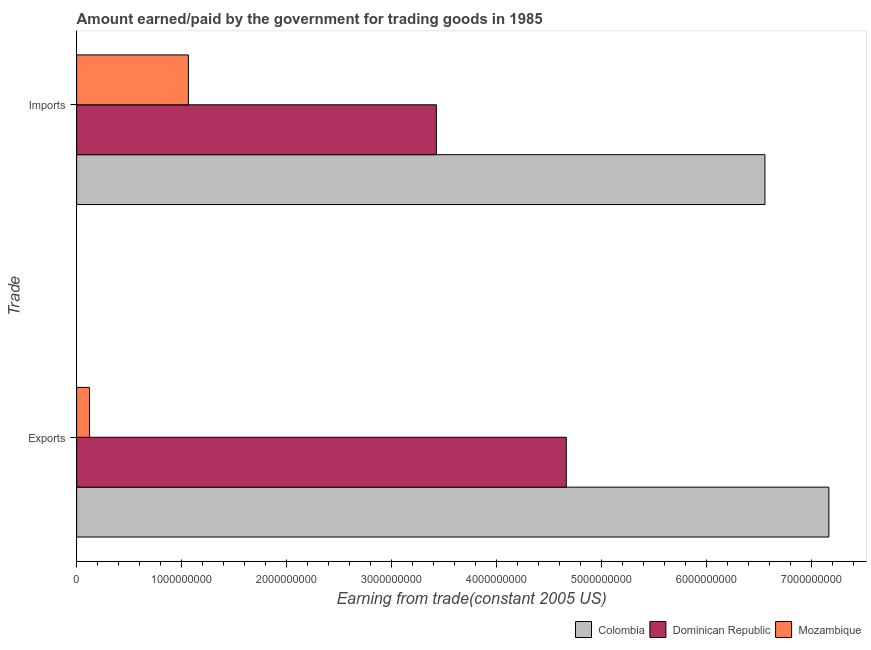How many different coloured bars are there?
Provide a short and direct response. 3. Are the number of bars per tick equal to the number of legend labels?
Your response must be concise. Yes. Are the number of bars on each tick of the Y-axis equal?
Make the answer very short. Yes. How many bars are there on the 2nd tick from the bottom?
Provide a short and direct response. 3. What is the label of the 2nd group of bars from the top?
Ensure brevity in your answer.  Exports. What is the amount paid for imports in Dominican Republic?
Ensure brevity in your answer.  3.43e+09. Across all countries, what is the maximum amount earned from exports?
Ensure brevity in your answer.  7.17e+09. Across all countries, what is the minimum amount paid for imports?
Make the answer very short. 1.06e+09. In which country was the amount earned from exports minimum?
Your response must be concise. Mozambique. What is the total amount earned from exports in the graph?
Make the answer very short. 1.20e+1. What is the difference between the amount earned from exports in Dominican Republic and that in Mozambique?
Provide a short and direct response. 4.54e+09. What is the difference between the amount earned from exports in Dominican Republic and the amount paid for imports in Mozambique?
Ensure brevity in your answer.  3.60e+09. What is the average amount earned from exports per country?
Offer a terse response. 3.98e+09. What is the difference between the amount paid for imports and amount earned from exports in Colombia?
Your answer should be compact. -6.09e+08. What is the ratio of the amount paid for imports in Mozambique to that in Colombia?
Your answer should be compact. 0.16. Is the amount paid for imports in Mozambique less than that in Dominican Republic?
Provide a succinct answer. Yes. In how many countries, is the amount paid for imports greater than the average amount paid for imports taken over all countries?
Make the answer very short. 1. What does the 1st bar from the top in Imports represents?
Keep it short and to the point. Mozambique. What does the 1st bar from the bottom in Imports represents?
Your answer should be very brief. Colombia. How many bars are there?
Your response must be concise. 6. Are the values on the major ticks of X-axis written in scientific E-notation?
Provide a succinct answer. No. Does the graph contain any zero values?
Make the answer very short. No. Where does the legend appear in the graph?
Offer a very short reply. Bottom right. How are the legend labels stacked?
Your answer should be compact. Horizontal. What is the title of the graph?
Offer a very short reply. Amount earned/paid by the government for trading goods in 1985. Does "Kosovo" appear as one of the legend labels in the graph?
Provide a succinct answer. No. What is the label or title of the X-axis?
Keep it short and to the point. Earning from trade(constant 2005 US). What is the label or title of the Y-axis?
Make the answer very short. Trade. What is the Earning from trade(constant 2005 US) in Colombia in Exports?
Make the answer very short. 7.17e+09. What is the Earning from trade(constant 2005 US) in Dominican Republic in Exports?
Keep it short and to the point. 4.66e+09. What is the Earning from trade(constant 2005 US) of Mozambique in Exports?
Your answer should be very brief. 1.22e+08. What is the Earning from trade(constant 2005 US) of Colombia in Imports?
Offer a very short reply. 6.56e+09. What is the Earning from trade(constant 2005 US) of Dominican Republic in Imports?
Provide a short and direct response. 3.43e+09. What is the Earning from trade(constant 2005 US) in Mozambique in Imports?
Make the answer very short. 1.06e+09. Across all Trade, what is the maximum Earning from trade(constant 2005 US) of Colombia?
Provide a short and direct response. 7.17e+09. Across all Trade, what is the maximum Earning from trade(constant 2005 US) in Dominican Republic?
Provide a succinct answer. 4.66e+09. Across all Trade, what is the maximum Earning from trade(constant 2005 US) of Mozambique?
Provide a short and direct response. 1.06e+09. Across all Trade, what is the minimum Earning from trade(constant 2005 US) of Colombia?
Make the answer very short. 6.56e+09. Across all Trade, what is the minimum Earning from trade(constant 2005 US) in Dominican Republic?
Your answer should be compact. 3.43e+09. Across all Trade, what is the minimum Earning from trade(constant 2005 US) in Mozambique?
Offer a very short reply. 1.22e+08. What is the total Earning from trade(constant 2005 US) of Colombia in the graph?
Your answer should be very brief. 1.37e+1. What is the total Earning from trade(constant 2005 US) of Dominican Republic in the graph?
Your response must be concise. 8.09e+09. What is the total Earning from trade(constant 2005 US) in Mozambique in the graph?
Provide a succinct answer. 1.19e+09. What is the difference between the Earning from trade(constant 2005 US) in Colombia in Exports and that in Imports?
Ensure brevity in your answer.  6.09e+08. What is the difference between the Earning from trade(constant 2005 US) in Dominican Republic in Exports and that in Imports?
Your answer should be very brief. 1.24e+09. What is the difference between the Earning from trade(constant 2005 US) in Mozambique in Exports and that in Imports?
Your answer should be very brief. -9.42e+08. What is the difference between the Earning from trade(constant 2005 US) of Colombia in Exports and the Earning from trade(constant 2005 US) of Dominican Republic in Imports?
Make the answer very short. 3.74e+09. What is the difference between the Earning from trade(constant 2005 US) in Colombia in Exports and the Earning from trade(constant 2005 US) in Mozambique in Imports?
Your answer should be compact. 6.10e+09. What is the difference between the Earning from trade(constant 2005 US) of Dominican Republic in Exports and the Earning from trade(constant 2005 US) of Mozambique in Imports?
Make the answer very short. 3.60e+09. What is the average Earning from trade(constant 2005 US) in Colombia per Trade?
Give a very brief answer. 6.86e+09. What is the average Earning from trade(constant 2005 US) of Dominican Republic per Trade?
Your response must be concise. 4.04e+09. What is the average Earning from trade(constant 2005 US) in Mozambique per Trade?
Ensure brevity in your answer.  5.93e+08. What is the difference between the Earning from trade(constant 2005 US) in Colombia and Earning from trade(constant 2005 US) in Dominican Republic in Exports?
Keep it short and to the point. 2.50e+09. What is the difference between the Earning from trade(constant 2005 US) in Colombia and Earning from trade(constant 2005 US) in Mozambique in Exports?
Your answer should be very brief. 7.04e+09. What is the difference between the Earning from trade(constant 2005 US) in Dominican Republic and Earning from trade(constant 2005 US) in Mozambique in Exports?
Give a very brief answer. 4.54e+09. What is the difference between the Earning from trade(constant 2005 US) of Colombia and Earning from trade(constant 2005 US) of Dominican Republic in Imports?
Offer a very short reply. 3.13e+09. What is the difference between the Earning from trade(constant 2005 US) in Colombia and Earning from trade(constant 2005 US) in Mozambique in Imports?
Ensure brevity in your answer.  5.49e+09. What is the difference between the Earning from trade(constant 2005 US) of Dominican Republic and Earning from trade(constant 2005 US) of Mozambique in Imports?
Make the answer very short. 2.36e+09. What is the ratio of the Earning from trade(constant 2005 US) in Colombia in Exports to that in Imports?
Make the answer very short. 1.09. What is the ratio of the Earning from trade(constant 2005 US) in Dominican Republic in Exports to that in Imports?
Keep it short and to the point. 1.36. What is the ratio of the Earning from trade(constant 2005 US) of Mozambique in Exports to that in Imports?
Your answer should be very brief. 0.11. What is the difference between the highest and the second highest Earning from trade(constant 2005 US) in Colombia?
Offer a terse response. 6.09e+08. What is the difference between the highest and the second highest Earning from trade(constant 2005 US) of Dominican Republic?
Provide a succinct answer. 1.24e+09. What is the difference between the highest and the second highest Earning from trade(constant 2005 US) of Mozambique?
Offer a terse response. 9.42e+08. What is the difference between the highest and the lowest Earning from trade(constant 2005 US) in Colombia?
Ensure brevity in your answer.  6.09e+08. What is the difference between the highest and the lowest Earning from trade(constant 2005 US) in Dominican Republic?
Keep it short and to the point. 1.24e+09. What is the difference between the highest and the lowest Earning from trade(constant 2005 US) of Mozambique?
Make the answer very short. 9.42e+08. 